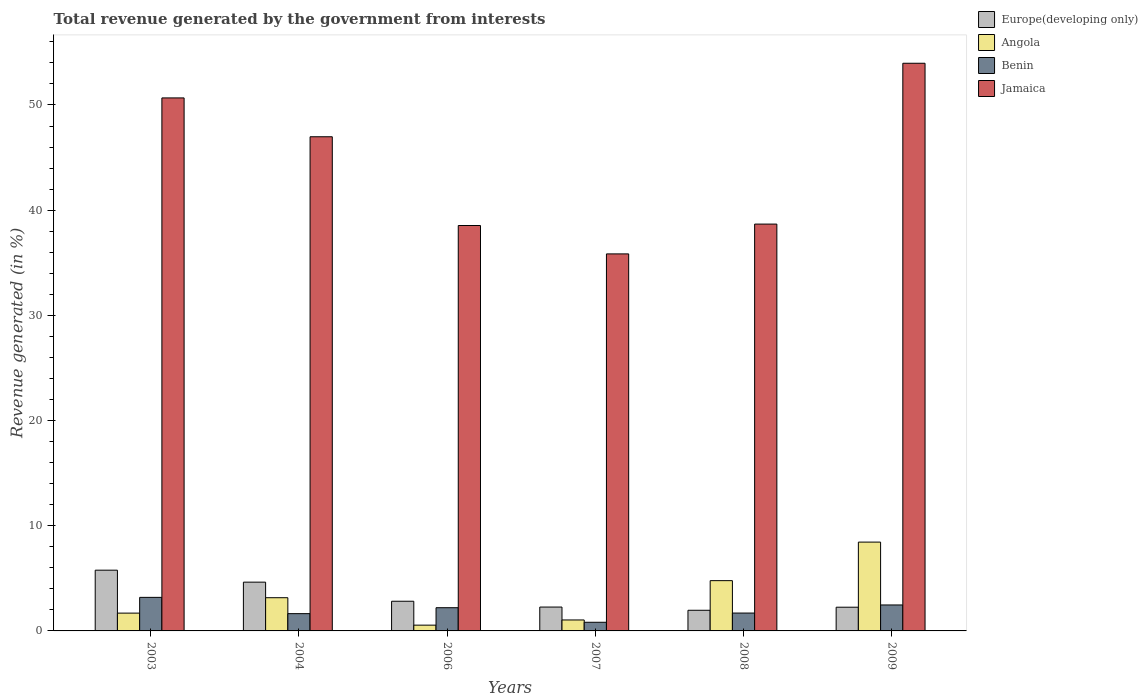How many groups of bars are there?
Your answer should be very brief. 6. Are the number of bars per tick equal to the number of legend labels?
Your answer should be compact. Yes. Are the number of bars on each tick of the X-axis equal?
Give a very brief answer. Yes. How many bars are there on the 2nd tick from the right?
Give a very brief answer. 4. In how many cases, is the number of bars for a given year not equal to the number of legend labels?
Your answer should be very brief. 0. What is the total revenue generated in Jamaica in 2007?
Provide a short and direct response. 35.84. Across all years, what is the maximum total revenue generated in Jamaica?
Offer a terse response. 53.97. Across all years, what is the minimum total revenue generated in Benin?
Your answer should be very brief. 0.82. In which year was the total revenue generated in Angola minimum?
Offer a terse response. 2006. What is the total total revenue generated in Europe(developing only) in the graph?
Make the answer very short. 19.72. What is the difference between the total revenue generated in Benin in 2003 and that in 2006?
Give a very brief answer. 0.98. What is the difference between the total revenue generated in Angola in 2003 and the total revenue generated in Benin in 2009?
Make the answer very short. -0.78. What is the average total revenue generated in Europe(developing only) per year?
Your response must be concise. 3.29. In the year 2003, what is the difference between the total revenue generated in Jamaica and total revenue generated in Angola?
Your response must be concise. 48.98. What is the ratio of the total revenue generated in Europe(developing only) in 2007 to that in 2008?
Ensure brevity in your answer.  1.16. Is the difference between the total revenue generated in Jamaica in 2004 and 2008 greater than the difference between the total revenue generated in Angola in 2004 and 2008?
Offer a terse response. Yes. What is the difference between the highest and the second highest total revenue generated in Benin?
Ensure brevity in your answer.  0.72. What is the difference between the highest and the lowest total revenue generated in Europe(developing only)?
Give a very brief answer. 3.81. In how many years, is the total revenue generated in Europe(developing only) greater than the average total revenue generated in Europe(developing only) taken over all years?
Provide a short and direct response. 2. What does the 1st bar from the left in 2008 represents?
Provide a short and direct response. Europe(developing only). What does the 1st bar from the right in 2006 represents?
Provide a succinct answer. Jamaica. Is it the case that in every year, the sum of the total revenue generated in Benin and total revenue generated in Angola is greater than the total revenue generated in Europe(developing only)?
Offer a terse response. No. Are all the bars in the graph horizontal?
Your answer should be compact. No. How many years are there in the graph?
Ensure brevity in your answer.  6. Are the values on the major ticks of Y-axis written in scientific E-notation?
Ensure brevity in your answer.  No. Does the graph contain grids?
Provide a short and direct response. No. Where does the legend appear in the graph?
Provide a short and direct response. Top right. How many legend labels are there?
Offer a very short reply. 4. How are the legend labels stacked?
Give a very brief answer. Vertical. What is the title of the graph?
Offer a very short reply. Total revenue generated by the government from interests. Does "Norway" appear as one of the legend labels in the graph?
Offer a terse response. No. What is the label or title of the X-axis?
Ensure brevity in your answer.  Years. What is the label or title of the Y-axis?
Keep it short and to the point. Revenue generated (in %). What is the Revenue generated (in %) in Europe(developing only) in 2003?
Make the answer very short. 5.78. What is the Revenue generated (in %) of Angola in 2003?
Ensure brevity in your answer.  1.69. What is the Revenue generated (in %) in Benin in 2003?
Give a very brief answer. 3.19. What is the Revenue generated (in %) in Jamaica in 2003?
Provide a succinct answer. 50.67. What is the Revenue generated (in %) in Europe(developing only) in 2004?
Your response must be concise. 4.64. What is the Revenue generated (in %) in Angola in 2004?
Offer a terse response. 3.16. What is the Revenue generated (in %) of Benin in 2004?
Your answer should be compact. 1.64. What is the Revenue generated (in %) in Jamaica in 2004?
Your answer should be very brief. 46.98. What is the Revenue generated (in %) in Europe(developing only) in 2006?
Your answer should be very brief. 2.82. What is the Revenue generated (in %) in Angola in 2006?
Offer a very short reply. 0.55. What is the Revenue generated (in %) of Benin in 2006?
Offer a terse response. 2.21. What is the Revenue generated (in %) in Jamaica in 2006?
Your response must be concise. 38.54. What is the Revenue generated (in %) of Europe(developing only) in 2007?
Your response must be concise. 2.27. What is the Revenue generated (in %) of Angola in 2007?
Provide a short and direct response. 1.04. What is the Revenue generated (in %) of Benin in 2007?
Offer a terse response. 0.82. What is the Revenue generated (in %) of Jamaica in 2007?
Ensure brevity in your answer.  35.84. What is the Revenue generated (in %) of Europe(developing only) in 2008?
Provide a short and direct response. 1.96. What is the Revenue generated (in %) of Angola in 2008?
Offer a terse response. 4.78. What is the Revenue generated (in %) of Benin in 2008?
Your response must be concise. 1.7. What is the Revenue generated (in %) of Jamaica in 2008?
Make the answer very short. 38.68. What is the Revenue generated (in %) in Europe(developing only) in 2009?
Provide a succinct answer. 2.25. What is the Revenue generated (in %) of Angola in 2009?
Ensure brevity in your answer.  8.44. What is the Revenue generated (in %) in Benin in 2009?
Offer a terse response. 2.47. What is the Revenue generated (in %) of Jamaica in 2009?
Provide a short and direct response. 53.97. Across all years, what is the maximum Revenue generated (in %) of Europe(developing only)?
Give a very brief answer. 5.78. Across all years, what is the maximum Revenue generated (in %) of Angola?
Your answer should be very brief. 8.44. Across all years, what is the maximum Revenue generated (in %) of Benin?
Offer a very short reply. 3.19. Across all years, what is the maximum Revenue generated (in %) of Jamaica?
Your answer should be very brief. 53.97. Across all years, what is the minimum Revenue generated (in %) in Europe(developing only)?
Your response must be concise. 1.96. Across all years, what is the minimum Revenue generated (in %) of Angola?
Ensure brevity in your answer.  0.55. Across all years, what is the minimum Revenue generated (in %) in Benin?
Give a very brief answer. 0.82. Across all years, what is the minimum Revenue generated (in %) of Jamaica?
Offer a terse response. 35.84. What is the total Revenue generated (in %) of Europe(developing only) in the graph?
Give a very brief answer. 19.72. What is the total Revenue generated (in %) in Angola in the graph?
Offer a very short reply. 19.66. What is the total Revenue generated (in %) in Benin in the graph?
Give a very brief answer. 12.03. What is the total Revenue generated (in %) in Jamaica in the graph?
Keep it short and to the point. 264.67. What is the difference between the Revenue generated (in %) in Europe(developing only) in 2003 and that in 2004?
Make the answer very short. 1.14. What is the difference between the Revenue generated (in %) of Angola in 2003 and that in 2004?
Offer a very short reply. -1.46. What is the difference between the Revenue generated (in %) of Benin in 2003 and that in 2004?
Make the answer very short. 1.55. What is the difference between the Revenue generated (in %) in Jamaica in 2003 and that in 2004?
Your answer should be compact. 3.69. What is the difference between the Revenue generated (in %) of Europe(developing only) in 2003 and that in 2006?
Ensure brevity in your answer.  2.95. What is the difference between the Revenue generated (in %) of Angola in 2003 and that in 2006?
Give a very brief answer. 1.14. What is the difference between the Revenue generated (in %) in Benin in 2003 and that in 2006?
Offer a terse response. 0.98. What is the difference between the Revenue generated (in %) of Jamaica in 2003 and that in 2006?
Give a very brief answer. 12.13. What is the difference between the Revenue generated (in %) of Europe(developing only) in 2003 and that in 2007?
Offer a terse response. 3.51. What is the difference between the Revenue generated (in %) of Angola in 2003 and that in 2007?
Your response must be concise. 0.65. What is the difference between the Revenue generated (in %) of Benin in 2003 and that in 2007?
Provide a short and direct response. 2.37. What is the difference between the Revenue generated (in %) in Jamaica in 2003 and that in 2007?
Provide a succinct answer. 14.83. What is the difference between the Revenue generated (in %) in Europe(developing only) in 2003 and that in 2008?
Provide a short and direct response. 3.81. What is the difference between the Revenue generated (in %) of Angola in 2003 and that in 2008?
Your response must be concise. -3.09. What is the difference between the Revenue generated (in %) of Benin in 2003 and that in 2008?
Give a very brief answer. 1.49. What is the difference between the Revenue generated (in %) in Jamaica in 2003 and that in 2008?
Give a very brief answer. 11.99. What is the difference between the Revenue generated (in %) in Europe(developing only) in 2003 and that in 2009?
Offer a terse response. 3.52. What is the difference between the Revenue generated (in %) in Angola in 2003 and that in 2009?
Make the answer very short. -6.75. What is the difference between the Revenue generated (in %) in Benin in 2003 and that in 2009?
Ensure brevity in your answer.  0.72. What is the difference between the Revenue generated (in %) in Jamaica in 2003 and that in 2009?
Ensure brevity in your answer.  -3.29. What is the difference between the Revenue generated (in %) of Europe(developing only) in 2004 and that in 2006?
Ensure brevity in your answer.  1.82. What is the difference between the Revenue generated (in %) in Angola in 2004 and that in 2006?
Provide a short and direct response. 2.61. What is the difference between the Revenue generated (in %) of Benin in 2004 and that in 2006?
Keep it short and to the point. -0.56. What is the difference between the Revenue generated (in %) in Jamaica in 2004 and that in 2006?
Provide a short and direct response. 8.44. What is the difference between the Revenue generated (in %) in Europe(developing only) in 2004 and that in 2007?
Offer a terse response. 2.37. What is the difference between the Revenue generated (in %) of Angola in 2004 and that in 2007?
Your answer should be compact. 2.12. What is the difference between the Revenue generated (in %) of Benin in 2004 and that in 2007?
Provide a short and direct response. 0.82. What is the difference between the Revenue generated (in %) of Jamaica in 2004 and that in 2007?
Provide a short and direct response. 11.14. What is the difference between the Revenue generated (in %) of Europe(developing only) in 2004 and that in 2008?
Make the answer very short. 2.67. What is the difference between the Revenue generated (in %) of Angola in 2004 and that in 2008?
Your answer should be compact. -1.62. What is the difference between the Revenue generated (in %) in Benin in 2004 and that in 2008?
Give a very brief answer. -0.06. What is the difference between the Revenue generated (in %) in Jamaica in 2004 and that in 2008?
Your response must be concise. 8.3. What is the difference between the Revenue generated (in %) in Europe(developing only) in 2004 and that in 2009?
Your answer should be very brief. 2.38. What is the difference between the Revenue generated (in %) of Angola in 2004 and that in 2009?
Offer a very short reply. -5.29. What is the difference between the Revenue generated (in %) in Benin in 2004 and that in 2009?
Your response must be concise. -0.83. What is the difference between the Revenue generated (in %) of Jamaica in 2004 and that in 2009?
Your answer should be very brief. -6.99. What is the difference between the Revenue generated (in %) in Europe(developing only) in 2006 and that in 2007?
Offer a very short reply. 0.55. What is the difference between the Revenue generated (in %) of Angola in 2006 and that in 2007?
Keep it short and to the point. -0.49. What is the difference between the Revenue generated (in %) of Benin in 2006 and that in 2007?
Keep it short and to the point. 1.38. What is the difference between the Revenue generated (in %) in Jamaica in 2006 and that in 2007?
Your answer should be very brief. 2.7. What is the difference between the Revenue generated (in %) in Europe(developing only) in 2006 and that in 2008?
Your answer should be very brief. 0.86. What is the difference between the Revenue generated (in %) of Angola in 2006 and that in 2008?
Your response must be concise. -4.23. What is the difference between the Revenue generated (in %) in Benin in 2006 and that in 2008?
Provide a succinct answer. 0.51. What is the difference between the Revenue generated (in %) in Jamaica in 2006 and that in 2008?
Your response must be concise. -0.14. What is the difference between the Revenue generated (in %) in Europe(developing only) in 2006 and that in 2009?
Ensure brevity in your answer.  0.57. What is the difference between the Revenue generated (in %) in Angola in 2006 and that in 2009?
Your answer should be very brief. -7.89. What is the difference between the Revenue generated (in %) in Benin in 2006 and that in 2009?
Provide a short and direct response. -0.26. What is the difference between the Revenue generated (in %) in Jamaica in 2006 and that in 2009?
Your answer should be compact. -15.42. What is the difference between the Revenue generated (in %) of Europe(developing only) in 2007 and that in 2008?
Your answer should be compact. 0.31. What is the difference between the Revenue generated (in %) in Angola in 2007 and that in 2008?
Offer a terse response. -3.74. What is the difference between the Revenue generated (in %) in Benin in 2007 and that in 2008?
Provide a short and direct response. -0.88. What is the difference between the Revenue generated (in %) of Jamaica in 2007 and that in 2008?
Make the answer very short. -2.83. What is the difference between the Revenue generated (in %) in Europe(developing only) in 2007 and that in 2009?
Provide a succinct answer. 0.01. What is the difference between the Revenue generated (in %) of Angola in 2007 and that in 2009?
Offer a very short reply. -7.4. What is the difference between the Revenue generated (in %) in Benin in 2007 and that in 2009?
Your response must be concise. -1.65. What is the difference between the Revenue generated (in %) in Jamaica in 2007 and that in 2009?
Your answer should be very brief. -18.12. What is the difference between the Revenue generated (in %) in Europe(developing only) in 2008 and that in 2009?
Provide a succinct answer. -0.29. What is the difference between the Revenue generated (in %) in Angola in 2008 and that in 2009?
Keep it short and to the point. -3.66. What is the difference between the Revenue generated (in %) in Benin in 2008 and that in 2009?
Your answer should be very brief. -0.77. What is the difference between the Revenue generated (in %) of Jamaica in 2008 and that in 2009?
Provide a succinct answer. -15.29. What is the difference between the Revenue generated (in %) in Europe(developing only) in 2003 and the Revenue generated (in %) in Angola in 2004?
Offer a terse response. 2.62. What is the difference between the Revenue generated (in %) in Europe(developing only) in 2003 and the Revenue generated (in %) in Benin in 2004?
Your answer should be very brief. 4.13. What is the difference between the Revenue generated (in %) in Europe(developing only) in 2003 and the Revenue generated (in %) in Jamaica in 2004?
Your answer should be very brief. -41.2. What is the difference between the Revenue generated (in %) of Angola in 2003 and the Revenue generated (in %) of Benin in 2004?
Offer a very short reply. 0.05. What is the difference between the Revenue generated (in %) in Angola in 2003 and the Revenue generated (in %) in Jamaica in 2004?
Offer a very short reply. -45.28. What is the difference between the Revenue generated (in %) in Benin in 2003 and the Revenue generated (in %) in Jamaica in 2004?
Your answer should be compact. -43.79. What is the difference between the Revenue generated (in %) of Europe(developing only) in 2003 and the Revenue generated (in %) of Angola in 2006?
Provide a short and direct response. 5.23. What is the difference between the Revenue generated (in %) of Europe(developing only) in 2003 and the Revenue generated (in %) of Benin in 2006?
Offer a very short reply. 3.57. What is the difference between the Revenue generated (in %) in Europe(developing only) in 2003 and the Revenue generated (in %) in Jamaica in 2006?
Make the answer very short. -32.77. What is the difference between the Revenue generated (in %) in Angola in 2003 and the Revenue generated (in %) in Benin in 2006?
Offer a very short reply. -0.51. What is the difference between the Revenue generated (in %) in Angola in 2003 and the Revenue generated (in %) in Jamaica in 2006?
Make the answer very short. -36.85. What is the difference between the Revenue generated (in %) of Benin in 2003 and the Revenue generated (in %) of Jamaica in 2006?
Offer a terse response. -35.35. What is the difference between the Revenue generated (in %) in Europe(developing only) in 2003 and the Revenue generated (in %) in Angola in 2007?
Make the answer very short. 4.73. What is the difference between the Revenue generated (in %) of Europe(developing only) in 2003 and the Revenue generated (in %) of Benin in 2007?
Your answer should be very brief. 4.95. What is the difference between the Revenue generated (in %) in Europe(developing only) in 2003 and the Revenue generated (in %) in Jamaica in 2007?
Your answer should be very brief. -30.07. What is the difference between the Revenue generated (in %) of Angola in 2003 and the Revenue generated (in %) of Benin in 2007?
Offer a very short reply. 0.87. What is the difference between the Revenue generated (in %) in Angola in 2003 and the Revenue generated (in %) in Jamaica in 2007?
Your answer should be very brief. -34.15. What is the difference between the Revenue generated (in %) of Benin in 2003 and the Revenue generated (in %) of Jamaica in 2007?
Provide a succinct answer. -32.65. What is the difference between the Revenue generated (in %) of Europe(developing only) in 2003 and the Revenue generated (in %) of Angola in 2008?
Your answer should be compact. 1. What is the difference between the Revenue generated (in %) of Europe(developing only) in 2003 and the Revenue generated (in %) of Benin in 2008?
Your answer should be compact. 4.08. What is the difference between the Revenue generated (in %) of Europe(developing only) in 2003 and the Revenue generated (in %) of Jamaica in 2008?
Make the answer very short. -32.9. What is the difference between the Revenue generated (in %) in Angola in 2003 and the Revenue generated (in %) in Benin in 2008?
Keep it short and to the point. -0.01. What is the difference between the Revenue generated (in %) in Angola in 2003 and the Revenue generated (in %) in Jamaica in 2008?
Give a very brief answer. -36.98. What is the difference between the Revenue generated (in %) of Benin in 2003 and the Revenue generated (in %) of Jamaica in 2008?
Provide a succinct answer. -35.49. What is the difference between the Revenue generated (in %) in Europe(developing only) in 2003 and the Revenue generated (in %) in Angola in 2009?
Keep it short and to the point. -2.67. What is the difference between the Revenue generated (in %) of Europe(developing only) in 2003 and the Revenue generated (in %) of Benin in 2009?
Provide a short and direct response. 3.31. What is the difference between the Revenue generated (in %) in Europe(developing only) in 2003 and the Revenue generated (in %) in Jamaica in 2009?
Your response must be concise. -48.19. What is the difference between the Revenue generated (in %) in Angola in 2003 and the Revenue generated (in %) in Benin in 2009?
Your answer should be very brief. -0.78. What is the difference between the Revenue generated (in %) of Angola in 2003 and the Revenue generated (in %) of Jamaica in 2009?
Provide a short and direct response. -52.27. What is the difference between the Revenue generated (in %) in Benin in 2003 and the Revenue generated (in %) in Jamaica in 2009?
Offer a terse response. -50.78. What is the difference between the Revenue generated (in %) in Europe(developing only) in 2004 and the Revenue generated (in %) in Angola in 2006?
Offer a terse response. 4.09. What is the difference between the Revenue generated (in %) in Europe(developing only) in 2004 and the Revenue generated (in %) in Benin in 2006?
Provide a succinct answer. 2.43. What is the difference between the Revenue generated (in %) of Europe(developing only) in 2004 and the Revenue generated (in %) of Jamaica in 2006?
Your answer should be compact. -33.9. What is the difference between the Revenue generated (in %) in Angola in 2004 and the Revenue generated (in %) in Benin in 2006?
Offer a terse response. 0.95. What is the difference between the Revenue generated (in %) of Angola in 2004 and the Revenue generated (in %) of Jamaica in 2006?
Your response must be concise. -35.38. What is the difference between the Revenue generated (in %) of Benin in 2004 and the Revenue generated (in %) of Jamaica in 2006?
Offer a very short reply. -36.9. What is the difference between the Revenue generated (in %) of Europe(developing only) in 2004 and the Revenue generated (in %) of Angola in 2007?
Your answer should be compact. 3.6. What is the difference between the Revenue generated (in %) in Europe(developing only) in 2004 and the Revenue generated (in %) in Benin in 2007?
Give a very brief answer. 3.81. What is the difference between the Revenue generated (in %) of Europe(developing only) in 2004 and the Revenue generated (in %) of Jamaica in 2007?
Make the answer very short. -31.2. What is the difference between the Revenue generated (in %) of Angola in 2004 and the Revenue generated (in %) of Benin in 2007?
Your response must be concise. 2.33. What is the difference between the Revenue generated (in %) in Angola in 2004 and the Revenue generated (in %) in Jamaica in 2007?
Your answer should be compact. -32.68. What is the difference between the Revenue generated (in %) of Benin in 2004 and the Revenue generated (in %) of Jamaica in 2007?
Keep it short and to the point. -34.2. What is the difference between the Revenue generated (in %) of Europe(developing only) in 2004 and the Revenue generated (in %) of Angola in 2008?
Give a very brief answer. -0.14. What is the difference between the Revenue generated (in %) of Europe(developing only) in 2004 and the Revenue generated (in %) of Benin in 2008?
Keep it short and to the point. 2.94. What is the difference between the Revenue generated (in %) in Europe(developing only) in 2004 and the Revenue generated (in %) in Jamaica in 2008?
Make the answer very short. -34.04. What is the difference between the Revenue generated (in %) in Angola in 2004 and the Revenue generated (in %) in Benin in 2008?
Your response must be concise. 1.46. What is the difference between the Revenue generated (in %) of Angola in 2004 and the Revenue generated (in %) of Jamaica in 2008?
Your answer should be compact. -35.52. What is the difference between the Revenue generated (in %) of Benin in 2004 and the Revenue generated (in %) of Jamaica in 2008?
Give a very brief answer. -37.03. What is the difference between the Revenue generated (in %) of Europe(developing only) in 2004 and the Revenue generated (in %) of Angola in 2009?
Your answer should be very brief. -3.81. What is the difference between the Revenue generated (in %) of Europe(developing only) in 2004 and the Revenue generated (in %) of Benin in 2009?
Offer a very short reply. 2.17. What is the difference between the Revenue generated (in %) of Europe(developing only) in 2004 and the Revenue generated (in %) of Jamaica in 2009?
Provide a succinct answer. -49.33. What is the difference between the Revenue generated (in %) of Angola in 2004 and the Revenue generated (in %) of Benin in 2009?
Ensure brevity in your answer.  0.69. What is the difference between the Revenue generated (in %) of Angola in 2004 and the Revenue generated (in %) of Jamaica in 2009?
Provide a succinct answer. -50.81. What is the difference between the Revenue generated (in %) of Benin in 2004 and the Revenue generated (in %) of Jamaica in 2009?
Provide a succinct answer. -52.32. What is the difference between the Revenue generated (in %) of Europe(developing only) in 2006 and the Revenue generated (in %) of Angola in 2007?
Make the answer very short. 1.78. What is the difference between the Revenue generated (in %) of Europe(developing only) in 2006 and the Revenue generated (in %) of Benin in 2007?
Keep it short and to the point. 2. What is the difference between the Revenue generated (in %) of Europe(developing only) in 2006 and the Revenue generated (in %) of Jamaica in 2007?
Provide a succinct answer. -33.02. What is the difference between the Revenue generated (in %) in Angola in 2006 and the Revenue generated (in %) in Benin in 2007?
Your answer should be compact. -0.27. What is the difference between the Revenue generated (in %) in Angola in 2006 and the Revenue generated (in %) in Jamaica in 2007?
Provide a short and direct response. -35.29. What is the difference between the Revenue generated (in %) of Benin in 2006 and the Revenue generated (in %) of Jamaica in 2007?
Offer a very short reply. -33.63. What is the difference between the Revenue generated (in %) of Europe(developing only) in 2006 and the Revenue generated (in %) of Angola in 2008?
Ensure brevity in your answer.  -1.96. What is the difference between the Revenue generated (in %) of Europe(developing only) in 2006 and the Revenue generated (in %) of Benin in 2008?
Your response must be concise. 1.12. What is the difference between the Revenue generated (in %) in Europe(developing only) in 2006 and the Revenue generated (in %) in Jamaica in 2008?
Your answer should be very brief. -35.85. What is the difference between the Revenue generated (in %) of Angola in 2006 and the Revenue generated (in %) of Benin in 2008?
Keep it short and to the point. -1.15. What is the difference between the Revenue generated (in %) in Angola in 2006 and the Revenue generated (in %) in Jamaica in 2008?
Your answer should be very brief. -38.13. What is the difference between the Revenue generated (in %) of Benin in 2006 and the Revenue generated (in %) of Jamaica in 2008?
Your response must be concise. -36.47. What is the difference between the Revenue generated (in %) in Europe(developing only) in 2006 and the Revenue generated (in %) in Angola in 2009?
Provide a succinct answer. -5.62. What is the difference between the Revenue generated (in %) in Europe(developing only) in 2006 and the Revenue generated (in %) in Benin in 2009?
Make the answer very short. 0.35. What is the difference between the Revenue generated (in %) in Europe(developing only) in 2006 and the Revenue generated (in %) in Jamaica in 2009?
Make the answer very short. -51.14. What is the difference between the Revenue generated (in %) in Angola in 2006 and the Revenue generated (in %) in Benin in 2009?
Provide a succinct answer. -1.92. What is the difference between the Revenue generated (in %) in Angola in 2006 and the Revenue generated (in %) in Jamaica in 2009?
Make the answer very short. -53.42. What is the difference between the Revenue generated (in %) of Benin in 2006 and the Revenue generated (in %) of Jamaica in 2009?
Provide a succinct answer. -51.76. What is the difference between the Revenue generated (in %) in Europe(developing only) in 2007 and the Revenue generated (in %) in Angola in 2008?
Keep it short and to the point. -2.51. What is the difference between the Revenue generated (in %) of Europe(developing only) in 2007 and the Revenue generated (in %) of Benin in 2008?
Make the answer very short. 0.57. What is the difference between the Revenue generated (in %) of Europe(developing only) in 2007 and the Revenue generated (in %) of Jamaica in 2008?
Give a very brief answer. -36.41. What is the difference between the Revenue generated (in %) of Angola in 2007 and the Revenue generated (in %) of Benin in 2008?
Your response must be concise. -0.66. What is the difference between the Revenue generated (in %) in Angola in 2007 and the Revenue generated (in %) in Jamaica in 2008?
Your response must be concise. -37.63. What is the difference between the Revenue generated (in %) of Benin in 2007 and the Revenue generated (in %) of Jamaica in 2008?
Provide a succinct answer. -37.85. What is the difference between the Revenue generated (in %) of Europe(developing only) in 2007 and the Revenue generated (in %) of Angola in 2009?
Provide a succinct answer. -6.18. What is the difference between the Revenue generated (in %) in Europe(developing only) in 2007 and the Revenue generated (in %) in Benin in 2009?
Your response must be concise. -0.2. What is the difference between the Revenue generated (in %) in Europe(developing only) in 2007 and the Revenue generated (in %) in Jamaica in 2009?
Provide a short and direct response. -51.7. What is the difference between the Revenue generated (in %) in Angola in 2007 and the Revenue generated (in %) in Benin in 2009?
Provide a short and direct response. -1.43. What is the difference between the Revenue generated (in %) of Angola in 2007 and the Revenue generated (in %) of Jamaica in 2009?
Your response must be concise. -52.92. What is the difference between the Revenue generated (in %) in Benin in 2007 and the Revenue generated (in %) in Jamaica in 2009?
Make the answer very short. -53.14. What is the difference between the Revenue generated (in %) of Europe(developing only) in 2008 and the Revenue generated (in %) of Angola in 2009?
Provide a succinct answer. -6.48. What is the difference between the Revenue generated (in %) of Europe(developing only) in 2008 and the Revenue generated (in %) of Benin in 2009?
Your response must be concise. -0.51. What is the difference between the Revenue generated (in %) in Europe(developing only) in 2008 and the Revenue generated (in %) in Jamaica in 2009?
Provide a short and direct response. -52. What is the difference between the Revenue generated (in %) of Angola in 2008 and the Revenue generated (in %) of Benin in 2009?
Provide a succinct answer. 2.31. What is the difference between the Revenue generated (in %) of Angola in 2008 and the Revenue generated (in %) of Jamaica in 2009?
Give a very brief answer. -49.19. What is the difference between the Revenue generated (in %) in Benin in 2008 and the Revenue generated (in %) in Jamaica in 2009?
Provide a short and direct response. -52.27. What is the average Revenue generated (in %) in Europe(developing only) per year?
Your answer should be compact. 3.29. What is the average Revenue generated (in %) of Angola per year?
Provide a succinct answer. 3.28. What is the average Revenue generated (in %) of Benin per year?
Ensure brevity in your answer.  2. What is the average Revenue generated (in %) in Jamaica per year?
Your response must be concise. 44.11. In the year 2003, what is the difference between the Revenue generated (in %) of Europe(developing only) and Revenue generated (in %) of Angola?
Make the answer very short. 4.08. In the year 2003, what is the difference between the Revenue generated (in %) of Europe(developing only) and Revenue generated (in %) of Benin?
Give a very brief answer. 2.59. In the year 2003, what is the difference between the Revenue generated (in %) in Europe(developing only) and Revenue generated (in %) in Jamaica?
Offer a terse response. -44.9. In the year 2003, what is the difference between the Revenue generated (in %) in Angola and Revenue generated (in %) in Benin?
Give a very brief answer. -1.5. In the year 2003, what is the difference between the Revenue generated (in %) of Angola and Revenue generated (in %) of Jamaica?
Give a very brief answer. -48.98. In the year 2003, what is the difference between the Revenue generated (in %) in Benin and Revenue generated (in %) in Jamaica?
Make the answer very short. -47.48. In the year 2004, what is the difference between the Revenue generated (in %) of Europe(developing only) and Revenue generated (in %) of Angola?
Provide a short and direct response. 1.48. In the year 2004, what is the difference between the Revenue generated (in %) in Europe(developing only) and Revenue generated (in %) in Benin?
Provide a succinct answer. 2.99. In the year 2004, what is the difference between the Revenue generated (in %) in Europe(developing only) and Revenue generated (in %) in Jamaica?
Give a very brief answer. -42.34. In the year 2004, what is the difference between the Revenue generated (in %) in Angola and Revenue generated (in %) in Benin?
Provide a succinct answer. 1.51. In the year 2004, what is the difference between the Revenue generated (in %) of Angola and Revenue generated (in %) of Jamaica?
Ensure brevity in your answer.  -43.82. In the year 2004, what is the difference between the Revenue generated (in %) of Benin and Revenue generated (in %) of Jamaica?
Your answer should be very brief. -45.34. In the year 2006, what is the difference between the Revenue generated (in %) of Europe(developing only) and Revenue generated (in %) of Angola?
Your response must be concise. 2.27. In the year 2006, what is the difference between the Revenue generated (in %) of Europe(developing only) and Revenue generated (in %) of Benin?
Keep it short and to the point. 0.61. In the year 2006, what is the difference between the Revenue generated (in %) in Europe(developing only) and Revenue generated (in %) in Jamaica?
Provide a succinct answer. -35.72. In the year 2006, what is the difference between the Revenue generated (in %) of Angola and Revenue generated (in %) of Benin?
Your response must be concise. -1.66. In the year 2006, what is the difference between the Revenue generated (in %) in Angola and Revenue generated (in %) in Jamaica?
Give a very brief answer. -37.99. In the year 2006, what is the difference between the Revenue generated (in %) of Benin and Revenue generated (in %) of Jamaica?
Keep it short and to the point. -36.33. In the year 2007, what is the difference between the Revenue generated (in %) of Europe(developing only) and Revenue generated (in %) of Angola?
Keep it short and to the point. 1.23. In the year 2007, what is the difference between the Revenue generated (in %) in Europe(developing only) and Revenue generated (in %) in Benin?
Offer a terse response. 1.45. In the year 2007, what is the difference between the Revenue generated (in %) of Europe(developing only) and Revenue generated (in %) of Jamaica?
Ensure brevity in your answer.  -33.57. In the year 2007, what is the difference between the Revenue generated (in %) of Angola and Revenue generated (in %) of Benin?
Make the answer very short. 0.22. In the year 2007, what is the difference between the Revenue generated (in %) in Angola and Revenue generated (in %) in Jamaica?
Your response must be concise. -34.8. In the year 2007, what is the difference between the Revenue generated (in %) of Benin and Revenue generated (in %) of Jamaica?
Your response must be concise. -35.02. In the year 2008, what is the difference between the Revenue generated (in %) of Europe(developing only) and Revenue generated (in %) of Angola?
Keep it short and to the point. -2.82. In the year 2008, what is the difference between the Revenue generated (in %) of Europe(developing only) and Revenue generated (in %) of Benin?
Provide a succinct answer. 0.26. In the year 2008, what is the difference between the Revenue generated (in %) in Europe(developing only) and Revenue generated (in %) in Jamaica?
Give a very brief answer. -36.71. In the year 2008, what is the difference between the Revenue generated (in %) in Angola and Revenue generated (in %) in Benin?
Give a very brief answer. 3.08. In the year 2008, what is the difference between the Revenue generated (in %) of Angola and Revenue generated (in %) of Jamaica?
Your answer should be very brief. -33.9. In the year 2008, what is the difference between the Revenue generated (in %) of Benin and Revenue generated (in %) of Jamaica?
Make the answer very short. -36.98. In the year 2009, what is the difference between the Revenue generated (in %) in Europe(developing only) and Revenue generated (in %) in Angola?
Make the answer very short. -6.19. In the year 2009, what is the difference between the Revenue generated (in %) of Europe(developing only) and Revenue generated (in %) of Benin?
Your answer should be compact. -0.21. In the year 2009, what is the difference between the Revenue generated (in %) in Europe(developing only) and Revenue generated (in %) in Jamaica?
Offer a very short reply. -51.71. In the year 2009, what is the difference between the Revenue generated (in %) of Angola and Revenue generated (in %) of Benin?
Ensure brevity in your answer.  5.98. In the year 2009, what is the difference between the Revenue generated (in %) of Angola and Revenue generated (in %) of Jamaica?
Your answer should be very brief. -45.52. In the year 2009, what is the difference between the Revenue generated (in %) in Benin and Revenue generated (in %) in Jamaica?
Ensure brevity in your answer.  -51.5. What is the ratio of the Revenue generated (in %) in Europe(developing only) in 2003 to that in 2004?
Your response must be concise. 1.25. What is the ratio of the Revenue generated (in %) in Angola in 2003 to that in 2004?
Give a very brief answer. 0.54. What is the ratio of the Revenue generated (in %) in Benin in 2003 to that in 2004?
Provide a short and direct response. 1.94. What is the ratio of the Revenue generated (in %) in Jamaica in 2003 to that in 2004?
Your answer should be compact. 1.08. What is the ratio of the Revenue generated (in %) of Europe(developing only) in 2003 to that in 2006?
Provide a succinct answer. 2.05. What is the ratio of the Revenue generated (in %) of Angola in 2003 to that in 2006?
Your response must be concise. 3.08. What is the ratio of the Revenue generated (in %) of Benin in 2003 to that in 2006?
Keep it short and to the point. 1.45. What is the ratio of the Revenue generated (in %) of Jamaica in 2003 to that in 2006?
Make the answer very short. 1.31. What is the ratio of the Revenue generated (in %) in Europe(developing only) in 2003 to that in 2007?
Your answer should be compact. 2.55. What is the ratio of the Revenue generated (in %) of Angola in 2003 to that in 2007?
Your answer should be very brief. 1.63. What is the ratio of the Revenue generated (in %) of Benin in 2003 to that in 2007?
Make the answer very short. 3.88. What is the ratio of the Revenue generated (in %) in Jamaica in 2003 to that in 2007?
Give a very brief answer. 1.41. What is the ratio of the Revenue generated (in %) in Europe(developing only) in 2003 to that in 2008?
Make the answer very short. 2.94. What is the ratio of the Revenue generated (in %) in Angola in 2003 to that in 2008?
Ensure brevity in your answer.  0.35. What is the ratio of the Revenue generated (in %) of Benin in 2003 to that in 2008?
Offer a terse response. 1.88. What is the ratio of the Revenue generated (in %) of Jamaica in 2003 to that in 2008?
Your answer should be compact. 1.31. What is the ratio of the Revenue generated (in %) of Europe(developing only) in 2003 to that in 2009?
Make the answer very short. 2.56. What is the ratio of the Revenue generated (in %) of Angola in 2003 to that in 2009?
Your answer should be compact. 0.2. What is the ratio of the Revenue generated (in %) of Benin in 2003 to that in 2009?
Give a very brief answer. 1.29. What is the ratio of the Revenue generated (in %) of Jamaica in 2003 to that in 2009?
Make the answer very short. 0.94. What is the ratio of the Revenue generated (in %) in Europe(developing only) in 2004 to that in 2006?
Provide a short and direct response. 1.64. What is the ratio of the Revenue generated (in %) in Angola in 2004 to that in 2006?
Give a very brief answer. 5.75. What is the ratio of the Revenue generated (in %) of Benin in 2004 to that in 2006?
Offer a terse response. 0.74. What is the ratio of the Revenue generated (in %) of Jamaica in 2004 to that in 2006?
Provide a short and direct response. 1.22. What is the ratio of the Revenue generated (in %) of Europe(developing only) in 2004 to that in 2007?
Offer a very short reply. 2.04. What is the ratio of the Revenue generated (in %) in Angola in 2004 to that in 2007?
Offer a terse response. 3.03. What is the ratio of the Revenue generated (in %) of Benin in 2004 to that in 2007?
Make the answer very short. 2. What is the ratio of the Revenue generated (in %) in Jamaica in 2004 to that in 2007?
Keep it short and to the point. 1.31. What is the ratio of the Revenue generated (in %) of Europe(developing only) in 2004 to that in 2008?
Provide a short and direct response. 2.36. What is the ratio of the Revenue generated (in %) of Angola in 2004 to that in 2008?
Offer a terse response. 0.66. What is the ratio of the Revenue generated (in %) in Benin in 2004 to that in 2008?
Offer a terse response. 0.97. What is the ratio of the Revenue generated (in %) in Jamaica in 2004 to that in 2008?
Provide a short and direct response. 1.21. What is the ratio of the Revenue generated (in %) in Europe(developing only) in 2004 to that in 2009?
Ensure brevity in your answer.  2.06. What is the ratio of the Revenue generated (in %) in Angola in 2004 to that in 2009?
Provide a short and direct response. 0.37. What is the ratio of the Revenue generated (in %) in Benin in 2004 to that in 2009?
Your response must be concise. 0.67. What is the ratio of the Revenue generated (in %) in Jamaica in 2004 to that in 2009?
Keep it short and to the point. 0.87. What is the ratio of the Revenue generated (in %) of Europe(developing only) in 2006 to that in 2007?
Keep it short and to the point. 1.24. What is the ratio of the Revenue generated (in %) of Angola in 2006 to that in 2007?
Offer a terse response. 0.53. What is the ratio of the Revenue generated (in %) in Benin in 2006 to that in 2007?
Offer a terse response. 2.68. What is the ratio of the Revenue generated (in %) of Jamaica in 2006 to that in 2007?
Make the answer very short. 1.08. What is the ratio of the Revenue generated (in %) in Europe(developing only) in 2006 to that in 2008?
Give a very brief answer. 1.44. What is the ratio of the Revenue generated (in %) in Angola in 2006 to that in 2008?
Ensure brevity in your answer.  0.12. What is the ratio of the Revenue generated (in %) of Benin in 2006 to that in 2008?
Your answer should be very brief. 1.3. What is the ratio of the Revenue generated (in %) of Europe(developing only) in 2006 to that in 2009?
Offer a terse response. 1.25. What is the ratio of the Revenue generated (in %) in Angola in 2006 to that in 2009?
Provide a succinct answer. 0.07. What is the ratio of the Revenue generated (in %) of Benin in 2006 to that in 2009?
Your response must be concise. 0.89. What is the ratio of the Revenue generated (in %) in Jamaica in 2006 to that in 2009?
Ensure brevity in your answer.  0.71. What is the ratio of the Revenue generated (in %) of Europe(developing only) in 2007 to that in 2008?
Provide a succinct answer. 1.16. What is the ratio of the Revenue generated (in %) in Angola in 2007 to that in 2008?
Offer a terse response. 0.22. What is the ratio of the Revenue generated (in %) in Benin in 2007 to that in 2008?
Provide a short and direct response. 0.48. What is the ratio of the Revenue generated (in %) of Jamaica in 2007 to that in 2008?
Offer a terse response. 0.93. What is the ratio of the Revenue generated (in %) in Europe(developing only) in 2007 to that in 2009?
Your answer should be compact. 1.01. What is the ratio of the Revenue generated (in %) of Angola in 2007 to that in 2009?
Provide a succinct answer. 0.12. What is the ratio of the Revenue generated (in %) in Benin in 2007 to that in 2009?
Provide a succinct answer. 0.33. What is the ratio of the Revenue generated (in %) in Jamaica in 2007 to that in 2009?
Give a very brief answer. 0.66. What is the ratio of the Revenue generated (in %) in Europe(developing only) in 2008 to that in 2009?
Keep it short and to the point. 0.87. What is the ratio of the Revenue generated (in %) in Angola in 2008 to that in 2009?
Make the answer very short. 0.57. What is the ratio of the Revenue generated (in %) in Benin in 2008 to that in 2009?
Give a very brief answer. 0.69. What is the ratio of the Revenue generated (in %) of Jamaica in 2008 to that in 2009?
Your answer should be very brief. 0.72. What is the difference between the highest and the second highest Revenue generated (in %) of Europe(developing only)?
Your answer should be compact. 1.14. What is the difference between the highest and the second highest Revenue generated (in %) of Angola?
Keep it short and to the point. 3.66. What is the difference between the highest and the second highest Revenue generated (in %) of Benin?
Offer a terse response. 0.72. What is the difference between the highest and the second highest Revenue generated (in %) in Jamaica?
Ensure brevity in your answer.  3.29. What is the difference between the highest and the lowest Revenue generated (in %) in Europe(developing only)?
Offer a terse response. 3.81. What is the difference between the highest and the lowest Revenue generated (in %) of Angola?
Ensure brevity in your answer.  7.89. What is the difference between the highest and the lowest Revenue generated (in %) of Benin?
Ensure brevity in your answer.  2.37. What is the difference between the highest and the lowest Revenue generated (in %) of Jamaica?
Offer a terse response. 18.12. 